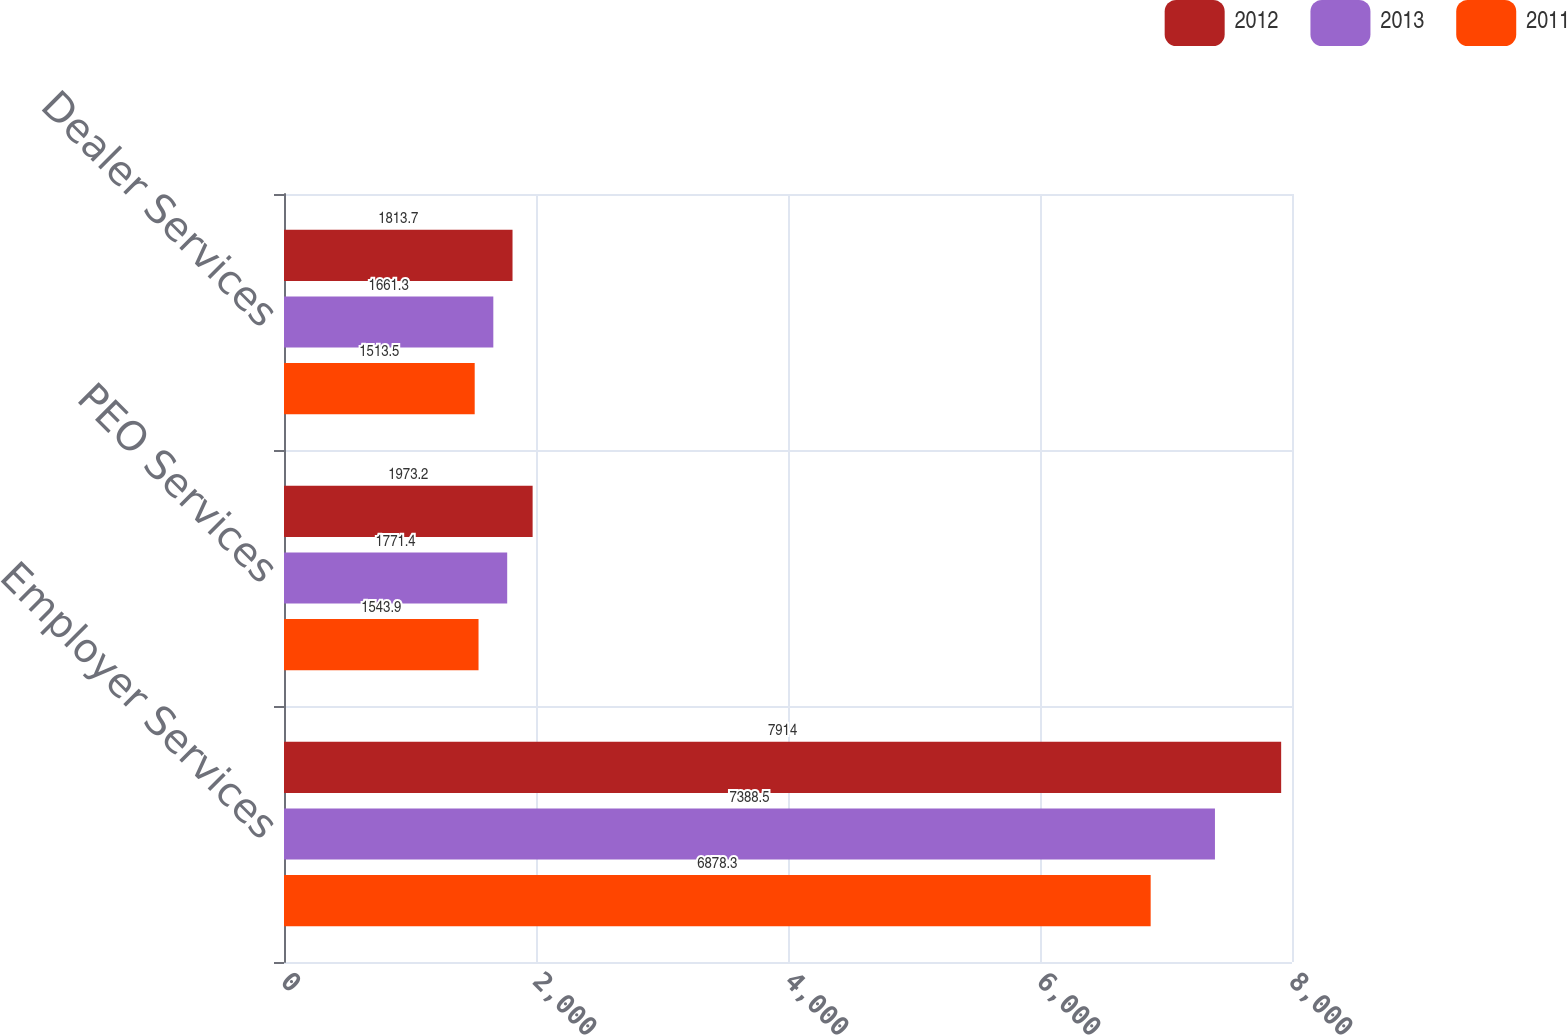<chart> <loc_0><loc_0><loc_500><loc_500><stacked_bar_chart><ecel><fcel>Employer Services<fcel>PEO Services<fcel>Dealer Services<nl><fcel>2012<fcel>7914<fcel>1973.2<fcel>1813.7<nl><fcel>2013<fcel>7388.5<fcel>1771.4<fcel>1661.3<nl><fcel>2011<fcel>6878.3<fcel>1543.9<fcel>1513.5<nl></chart> 